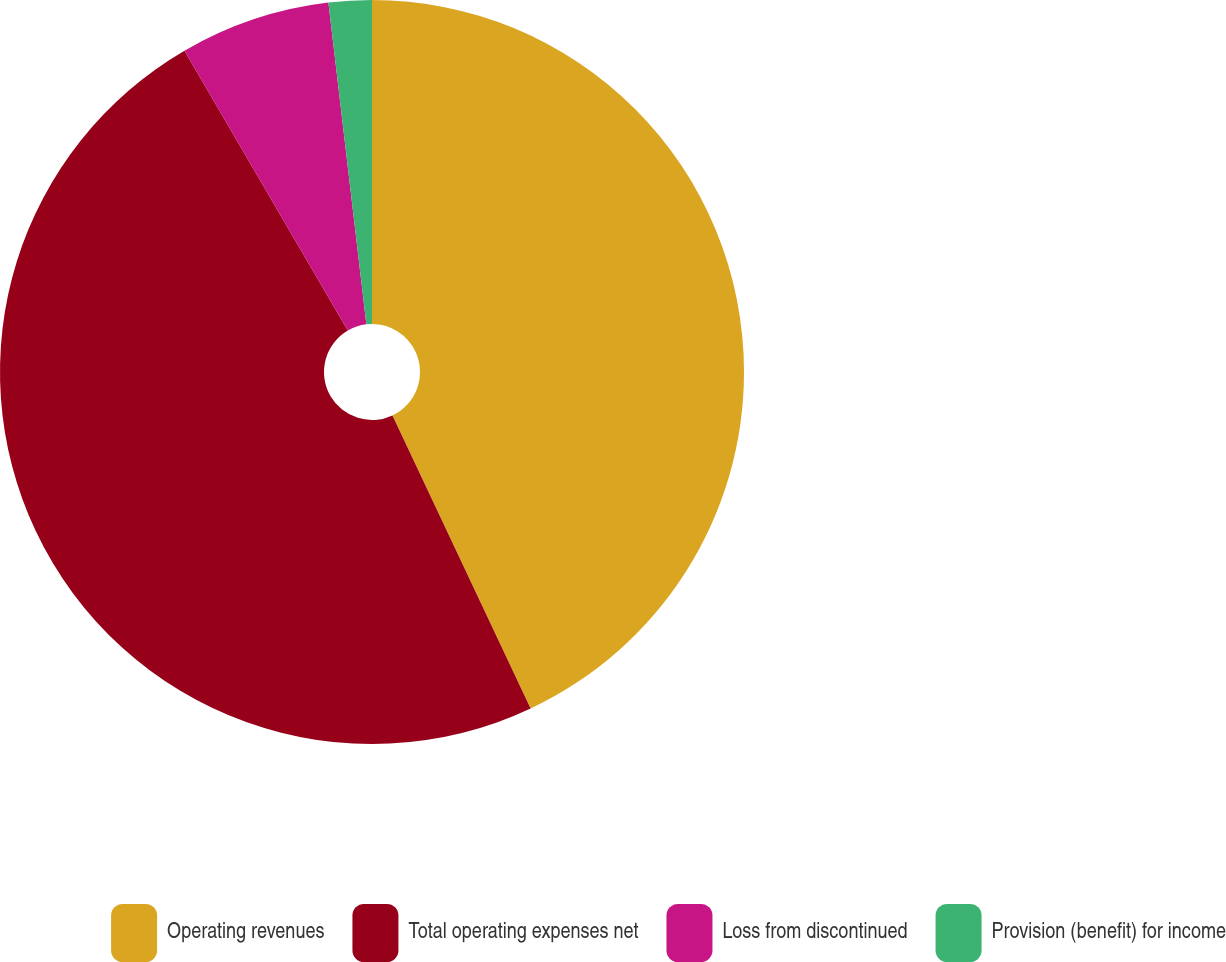Convert chart to OTSL. <chart><loc_0><loc_0><loc_500><loc_500><pie_chart><fcel>Operating revenues<fcel>Total operating expenses net<fcel>Loss from discontinued<fcel>Provision (benefit) for income<nl><fcel>42.99%<fcel>48.6%<fcel>6.54%<fcel>1.87%<nl></chart> 